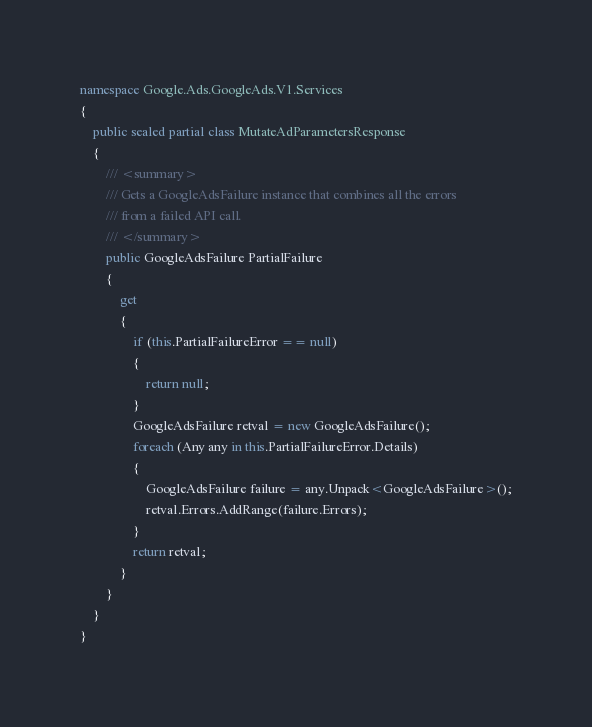Convert code to text. <code><loc_0><loc_0><loc_500><loc_500><_C#_>namespace Google.Ads.GoogleAds.V1.Services
{
    public sealed partial class MutateAdParametersResponse 
    {
        /// <summary>
        /// Gets a GoogleAdsFailure instance that combines all the errors
        /// from a failed API call.
        /// </summary>
        public GoogleAdsFailure PartialFailure
        {
            get
            {
                if (this.PartialFailureError == null)
                {
                    return null;
                }
                GoogleAdsFailure retval = new GoogleAdsFailure();
                foreach (Any any in this.PartialFailureError.Details)
                {
                    GoogleAdsFailure failure = any.Unpack<GoogleAdsFailure>();
                    retval.Errors.AddRange(failure.Errors);
                }
                return retval;
            }
        }
    }
}
</code> 